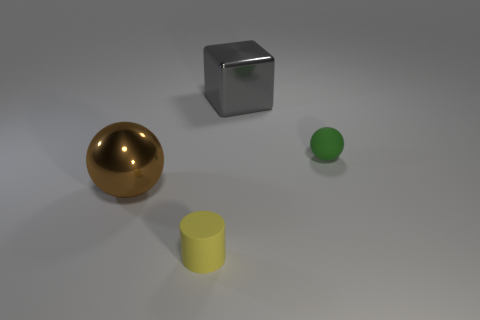What number of other objects are the same material as the small green thing?
Offer a very short reply. 1. How many things are large green cubes or objects that are behind the large brown metallic object?
Keep it short and to the point. 2. Is the number of matte objects less than the number of large gray metallic cylinders?
Offer a very short reply. No. There is a tiny matte object that is on the right side of the matte object that is in front of the big thing in front of the large gray shiny cube; what color is it?
Offer a terse response. Green. Is the big sphere made of the same material as the small green sphere?
Ensure brevity in your answer.  No. There is a metallic sphere; what number of green spheres are in front of it?
Your answer should be compact. 0. What is the size of the green object that is the same shape as the brown object?
Your response must be concise. Small. What number of yellow objects are either shiny cubes or rubber objects?
Ensure brevity in your answer.  1. What number of large brown metal things are behind the rubber thing on the left side of the big metal block?
Your response must be concise. 1. How many other objects are the same shape as the yellow thing?
Ensure brevity in your answer.  0. 